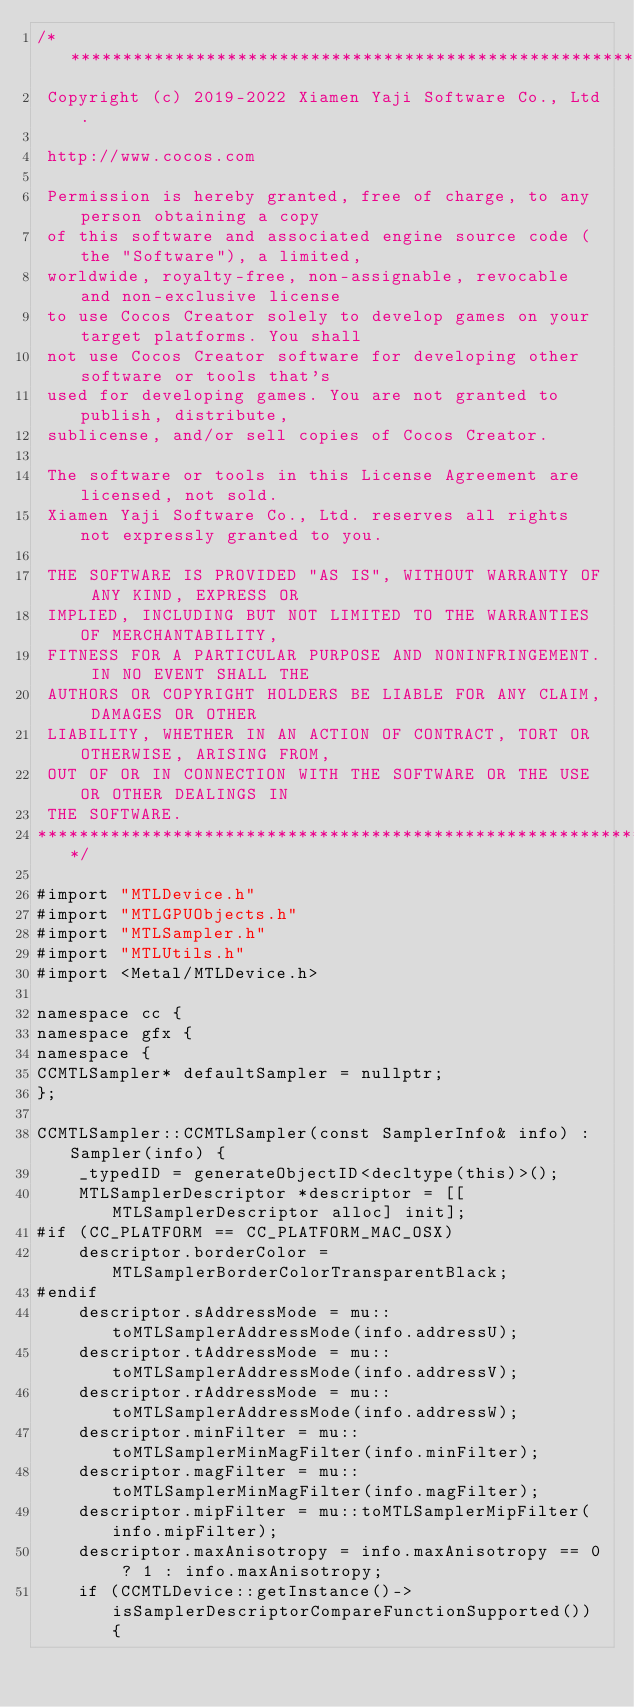Convert code to text. <code><loc_0><loc_0><loc_500><loc_500><_ObjectiveC_>/****************************************************************************
 Copyright (c) 2019-2022 Xiamen Yaji Software Co., Ltd.

 http://www.cocos.com

 Permission is hereby granted, free of charge, to any person obtaining a copy
 of this software and associated engine source code (the "Software"), a limited,
 worldwide, royalty-free, non-assignable, revocable and non-exclusive license
 to use Cocos Creator solely to develop games on your target platforms. You shall
 not use Cocos Creator software for developing other software or tools that's
 used for developing games. You are not granted to publish, distribute,
 sublicense, and/or sell copies of Cocos Creator.

 The software or tools in this License Agreement are licensed, not sold.
 Xiamen Yaji Software Co., Ltd. reserves all rights not expressly granted to you.

 THE SOFTWARE IS PROVIDED "AS IS", WITHOUT WARRANTY OF ANY KIND, EXPRESS OR
 IMPLIED, INCLUDING BUT NOT LIMITED TO THE WARRANTIES OF MERCHANTABILITY,
 FITNESS FOR A PARTICULAR PURPOSE AND NONINFRINGEMENT. IN NO EVENT SHALL THE
 AUTHORS OR COPYRIGHT HOLDERS BE LIABLE FOR ANY CLAIM, DAMAGES OR OTHER
 LIABILITY, WHETHER IN AN ACTION OF CONTRACT, TORT OR OTHERWISE, ARISING FROM,
 OUT OF OR IN CONNECTION WITH THE SOFTWARE OR THE USE OR OTHER DEALINGS IN
 THE SOFTWARE.
****************************************************************************/

#import "MTLDevice.h"
#import "MTLGPUObjects.h"
#import "MTLSampler.h"
#import "MTLUtils.h"
#import <Metal/MTLDevice.h>

namespace cc {
namespace gfx {
namespace {
CCMTLSampler* defaultSampler = nullptr;
};

CCMTLSampler::CCMTLSampler(const SamplerInfo& info) : Sampler(info) {
    _typedID = generateObjectID<decltype(this)>();
    MTLSamplerDescriptor *descriptor = [[MTLSamplerDescriptor alloc] init];
#if (CC_PLATFORM == CC_PLATFORM_MAC_OSX)
    descriptor.borderColor = MTLSamplerBorderColorTransparentBlack;
#endif
    descriptor.sAddressMode = mu::toMTLSamplerAddressMode(info.addressU);
    descriptor.tAddressMode = mu::toMTLSamplerAddressMode(info.addressV);
    descriptor.rAddressMode = mu::toMTLSamplerAddressMode(info.addressW);
    descriptor.minFilter = mu::toMTLSamplerMinMagFilter(info.minFilter);
    descriptor.magFilter = mu::toMTLSamplerMinMagFilter(info.magFilter);
    descriptor.mipFilter = mu::toMTLSamplerMipFilter(info.mipFilter);
    descriptor.maxAnisotropy = info.maxAnisotropy == 0 ? 1 : info.maxAnisotropy;
    if (CCMTLDevice::getInstance()->isSamplerDescriptorCompareFunctionSupported()) {</code> 